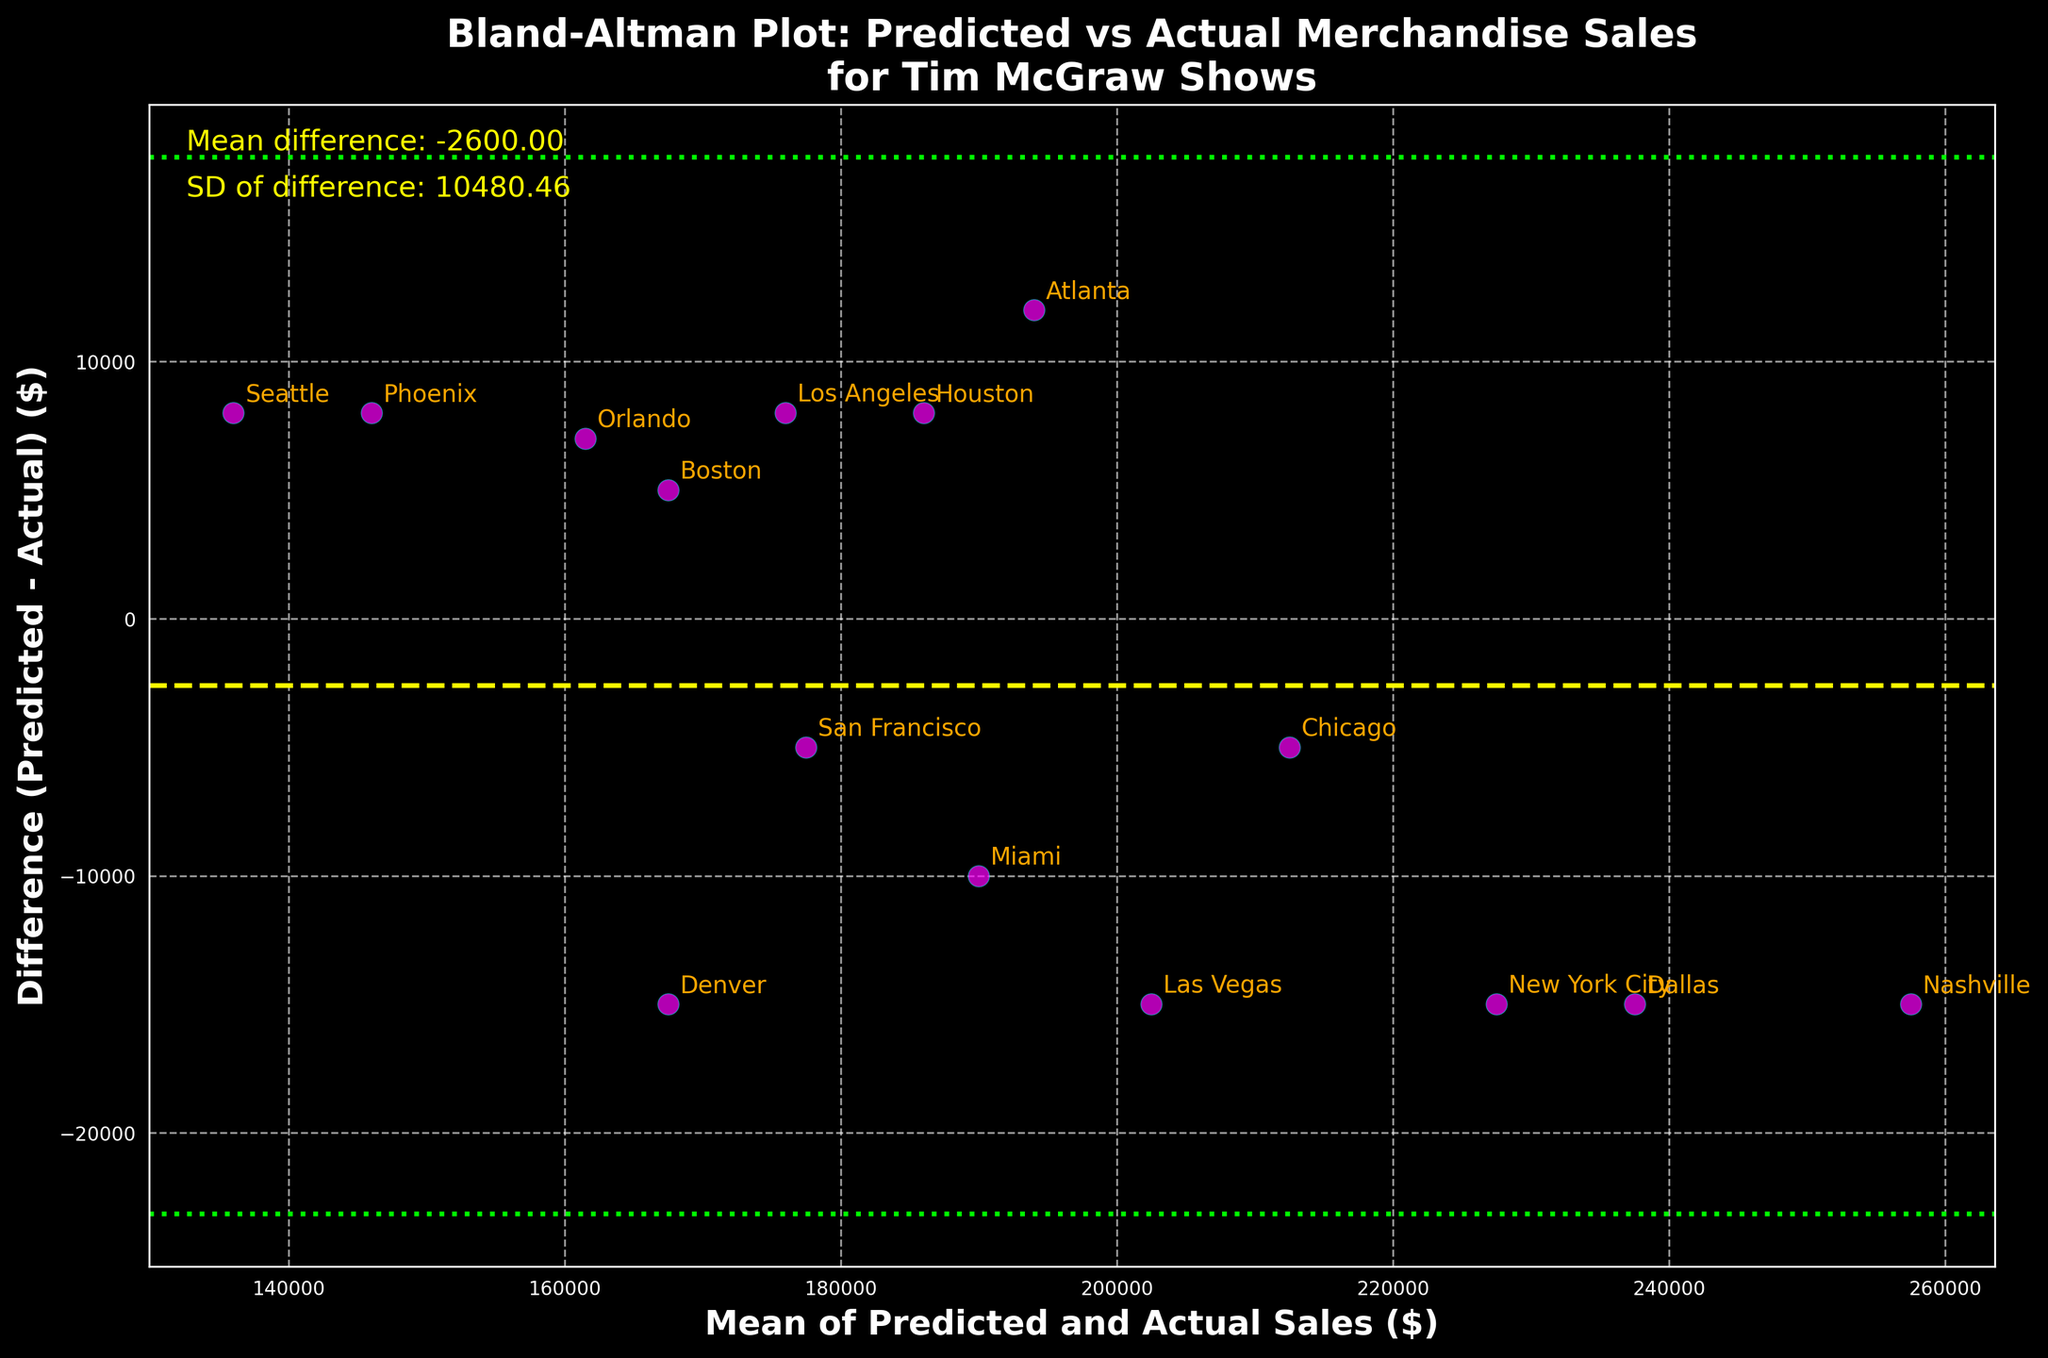What is the title of the plot? The title is displayed at the top of the plot and reads "Bland-Altman Plot: Predicted vs Actual Merchandise Sales for Tim McGraw Shows."
Answer: Bland-Altman Plot: Predicted vs Actual Merchandise Sales for Tim McGraw Shows How many data points are plotted? Each data point represents a region, and there are 15 regions listed in the data. Therefore, there are 15 data points.
Answer: 15 What does the yellow dashed line represent? The yellow dashed line represents the mean difference between predicted and actual sales. The mean difference is calculated as the average of all the differences (Predicted - Actual).
Answer: Mean difference Which region has the largest positive difference between predicted and actual sales? The largest positive difference can be found by looking at the point with the highest position on the y-axis (above the mean difference line). According to the plot, Dallas has the largest positive difference.
Answer: Dallas Which region has the largest negative difference between predicted and actual sales? The largest negative difference can be found by looking at the point with the lowest position on the y-axis (below the mean difference line). According to the plot, Phoenix has the largest negative difference.
Answer: Phoenix Are there any points that lie outside the limits of agreement? Points that lie outside the limits of agreement are those located above the upper or below the lower lime-colored dotted lines. The plot should be checked for any such points. Based on the plot, Dallas has a point slightly above the upper limit.
Answer: Yes, Dallas What is the mean of the differences (Predicted - Actual) in sales? The mean difference is explicitly stated in the text on the plot. It reads: "Mean difference: -3,666.67". The mean difference in sales is -3,666.67.
Answer: -3,666.67 What is the standard deviation of the differences in sales? The standard deviation is also provided in the text on the plot. It reads: "SD of difference: 17,895.76".
Answer: 17,895.76 Between which two values do the limits of agreement lie? The limits of agreement are calculated as the mean difference plus and minus 1.96 times the standard deviation. These limits are visualized by the lime-colored dotted lines on the plot. The upper and lower limits can be determined accordingly:
Upper limit = -3,666.67 + (1.96 * 17,895.76) ≈ 31,449.70;
Lower limit = -3,666.67 - (1.96 * 17,895.76) ≈ -38,782.03
Answer: Between -38,782.03 and 31,449.70 Which regions fall near the mean difference line? Regions that fall near the yellow dashed mean difference line have differences close to zero. From the plot, regions like Boston, Los Angeles, and Houston are near the mean difference line.
Answer: Boston, Los Angeles, Houston 